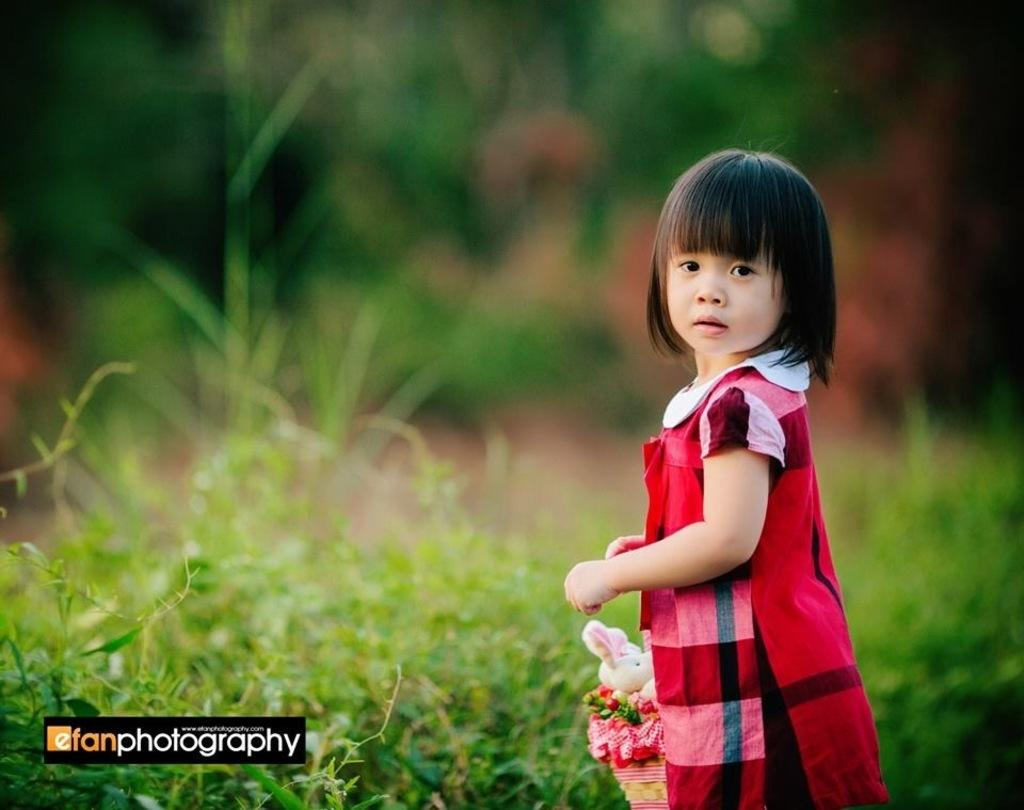<image>
Render a clear and concise summary of the photo. A little girl standing outdoors by efan photography. 